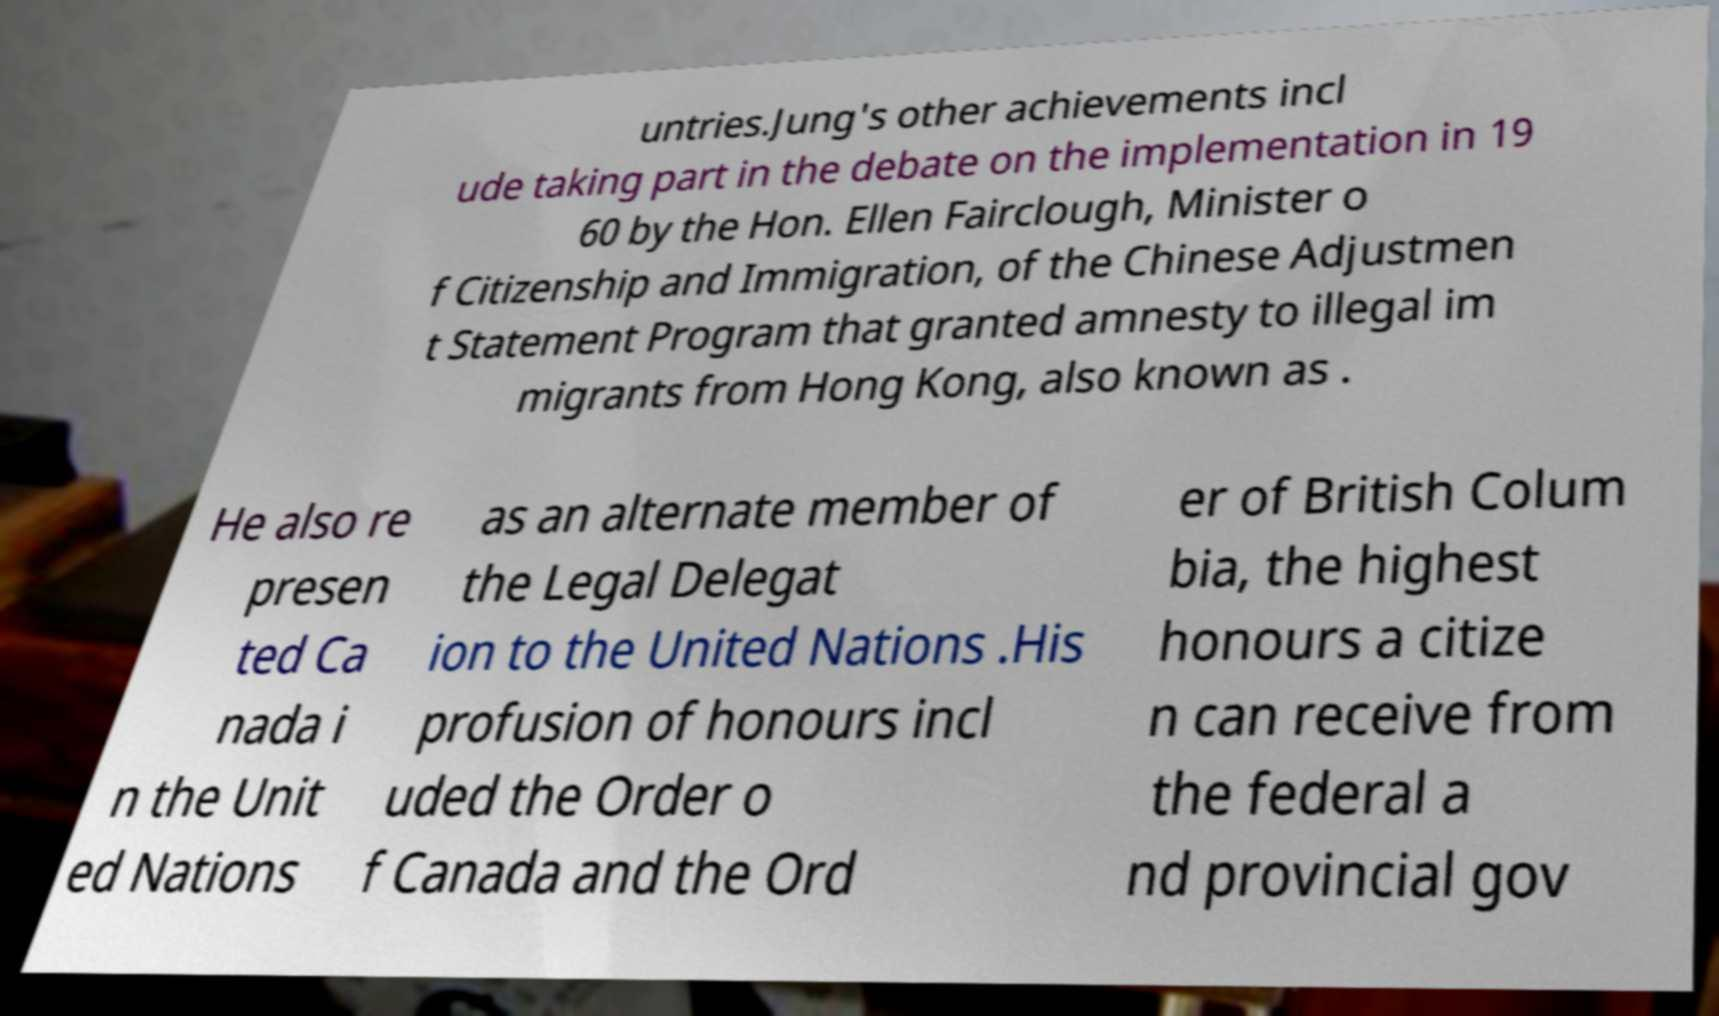Please read and relay the text visible in this image. What does it say? untries.Jung's other achievements incl ude taking part in the debate on the implementation in 19 60 by the Hon. Ellen Fairclough, Minister o f Citizenship and Immigration, of the Chinese Adjustmen t Statement Program that granted amnesty to illegal im migrants from Hong Kong, also known as . He also re presen ted Ca nada i n the Unit ed Nations as an alternate member of the Legal Delegat ion to the United Nations .His profusion of honours incl uded the Order o f Canada and the Ord er of British Colum bia, the highest honours a citize n can receive from the federal a nd provincial gov 